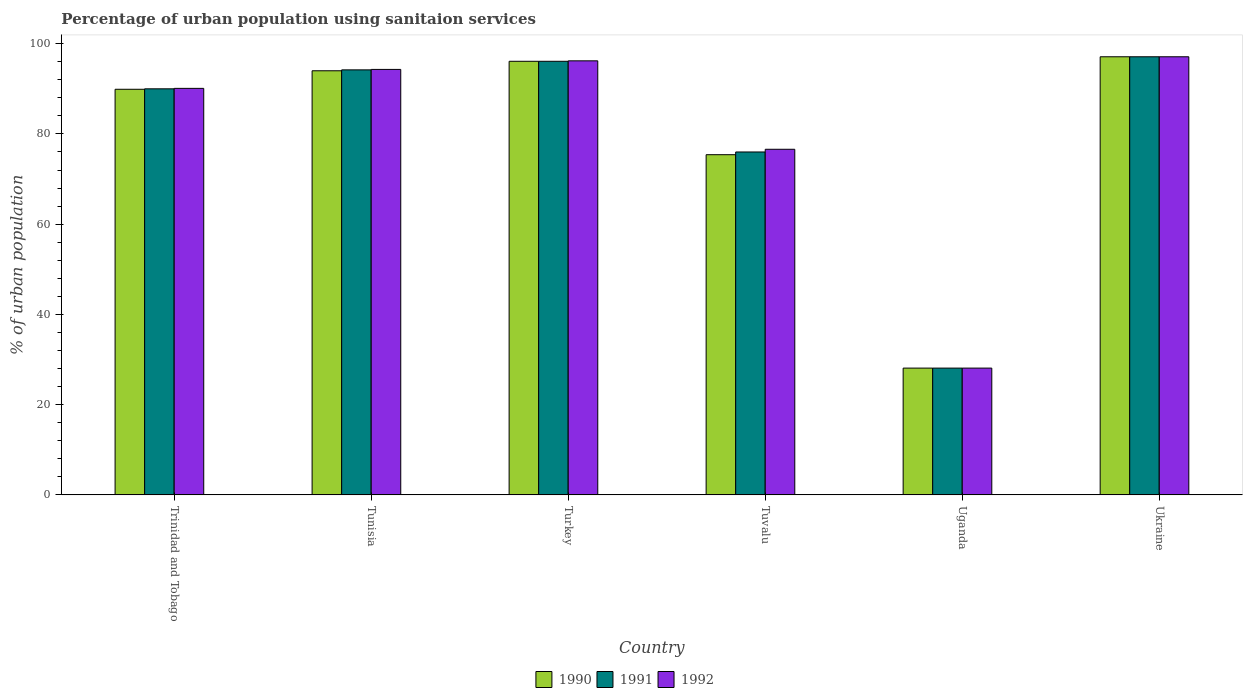How many different coloured bars are there?
Your answer should be very brief. 3. How many groups of bars are there?
Keep it short and to the point. 6. Are the number of bars per tick equal to the number of legend labels?
Offer a terse response. Yes. Are the number of bars on each tick of the X-axis equal?
Offer a terse response. Yes. How many bars are there on the 6th tick from the left?
Provide a succinct answer. 3. What is the label of the 4th group of bars from the left?
Offer a terse response. Tuvalu. What is the percentage of urban population using sanitaion services in 1992 in Trinidad and Tobago?
Your response must be concise. 90.1. Across all countries, what is the maximum percentage of urban population using sanitaion services in 1991?
Give a very brief answer. 97.1. Across all countries, what is the minimum percentage of urban population using sanitaion services in 1992?
Offer a very short reply. 28.1. In which country was the percentage of urban population using sanitaion services in 1992 maximum?
Your response must be concise. Ukraine. In which country was the percentage of urban population using sanitaion services in 1992 minimum?
Provide a succinct answer. Uganda. What is the total percentage of urban population using sanitaion services in 1990 in the graph?
Your answer should be compact. 480.6. What is the difference between the percentage of urban population using sanitaion services in 1992 in Trinidad and Tobago and the percentage of urban population using sanitaion services in 1990 in Uganda?
Ensure brevity in your answer.  62. What is the average percentage of urban population using sanitaion services in 1992 per country?
Offer a very short reply. 80.4. What is the difference between the percentage of urban population using sanitaion services of/in 1990 and percentage of urban population using sanitaion services of/in 1991 in Tuvalu?
Keep it short and to the point. -0.6. In how many countries, is the percentage of urban population using sanitaion services in 1991 greater than 44 %?
Your answer should be very brief. 5. What is the ratio of the percentage of urban population using sanitaion services in 1992 in Trinidad and Tobago to that in Uganda?
Your response must be concise. 3.21. Is the percentage of urban population using sanitaion services in 1991 in Tunisia less than that in Tuvalu?
Keep it short and to the point. No. What is the difference between the highest and the second highest percentage of urban population using sanitaion services in 1992?
Your answer should be compact. -0.9. What is the difference between the highest and the lowest percentage of urban population using sanitaion services in 1990?
Give a very brief answer. 69. What does the 3rd bar from the left in Ukraine represents?
Your answer should be compact. 1992. What does the 3rd bar from the right in Tuvalu represents?
Offer a very short reply. 1990. Is it the case that in every country, the sum of the percentage of urban population using sanitaion services in 1992 and percentage of urban population using sanitaion services in 1991 is greater than the percentage of urban population using sanitaion services in 1990?
Ensure brevity in your answer.  Yes. How many bars are there?
Offer a terse response. 18. Are all the bars in the graph horizontal?
Give a very brief answer. No. How many countries are there in the graph?
Keep it short and to the point. 6. Are the values on the major ticks of Y-axis written in scientific E-notation?
Your answer should be compact. No. Does the graph contain grids?
Make the answer very short. No. Where does the legend appear in the graph?
Offer a very short reply. Bottom center. How many legend labels are there?
Offer a very short reply. 3. What is the title of the graph?
Provide a succinct answer. Percentage of urban population using sanitaion services. What is the label or title of the Y-axis?
Keep it short and to the point. % of urban population. What is the % of urban population of 1990 in Trinidad and Tobago?
Your answer should be compact. 89.9. What is the % of urban population in 1991 in Trinidad and Tobago?
Keep it short and to the point. 90. What is the % of urban population in 1992 in Trinidad and Tobago?
Your response must be concise. 90.1. What is the % of urban population of 1990 in Tunisia?
Offer a very short reply. 94. What is the % of urban population of 1991 in Tunisia?
Offer a terse response. 94.2. What is the % of urban population in 1992 in Tunisia?
Provide a short and direct response. 94.3. What is the % of urban population in 1990 in Turkey?
Ensure brevity in your answer.  96.1. What is the % of urban population of 1991 in Turkey?
Provide a short and direct response. 96.1. What is the % of urban population in 1992 in Turkey?
Offer a terse response. 96.2. What is the % of urban population of 1990 in Tuvalu?
Give a very brief answer. 75.4. What is the % of urban population of 1992 in Tuvalu?
Offer a terse response. 76.6. What is the % of urban population of 1990 in Uganda?
Make the answer very short. 28.1. What is the % of urban population in 1991 in Uganda?
Provide a short and direct response. 28.1. What is the % of urban population of 1992 in Uganda?
Offer a terse response. 28.1. What is the % of urban population in 1990 in Ukraine?
Provide a succinct answer. 97.1. What is the % of urban population of 1991 in Ukraine?
Provide a short and direct response. 97.1. What is the % of urban population of 1992 in Ukraine?
Give a very brief answer. 97.1. Across all countries, what is the maximum % of urban population of 1990?
Offer a terse response. 97.1. Across all countries, what is the maximum % of urban population of 1991?
Your answer should be very brief. 97.1. Across all countries, what is the maximum % of urban population in 1992?
Provide a succinct answer. 97.1. Across all countries, what is the minimum % of urban population in 1990?
Your answer should be very brief. 28.1. Across all countries, what is the minimum % of urban population in 1991?
Give a very brief answer. 28.1. Across all countries, what is the minimum % of urban population in 1992?
Provide a succinct answer. 28.1. What is the total % of urban population of 1990 in the graph?
Provide a succinct answer. 480.6. What is the total % of urban population of 1991 in the graph?
Give a very brief answer. 481.5. What is the total % of urban population of 1992 in the graph?
Your answer should be compact. 482.4. What is the difference between the % of urban population in 1990 in Trinidad and Tobago and that in Tunisia?
Ensure brevity in your answer.  -4.1. What is the difference between the % of urban population in 1991 in Trinidad and Tobago and that in Tunisia?
Give a very brief answer. -4.2. What is the difference between the % of urban population in 1990 in Trinidad and Tobago and that in Turkey?
Give a very brief answer. -6.2. What is the difference between the % of urban population of 1992 in Trinidad and Tobago and that in Turkey?
Offer a very short reply. -6.1. What is the difference between the % of urban population of 1990 in Trinidad and Tobago and that in Tuvalu?
Offer a terse response. 14.5. What is the difference between the % of urban population in 1991 in Trinidad and Tobago and that in Tuvalu?
Keep it short and to the point. 14. What is the difference between the % of urban population in 1992 in Trinidad and Tobago and that in Tuvalu?
Your answer should be very brief. 13.5. What is the difference between the % of urban population of 1990 in Trinidad and Tobago and that in Uganda?
Make the answer very short. 61.8. What is the difference between the % of urban population of 1991 in Trinidad and Tobago and that in Uganda?
Keep it short and to the point. 61.9. What is the difference between the % of urban population in 1992 in Trinidad and Tobago and that in Uganda?
Make the answer very short. 62. What is the difference between the % of urban population in 1990 in Trinidad and Tobago and that in Ukraine?
Your response must be concise. -7.2. What is the difference between the % of urban population in 1991 in Trinidad and Tobago and that in Ukraine?
Make the answer very short. -7.1. What is the difference between the % of urban population in 1990 in Tunisia and that in Uganda?
Offer a terse response. 65.9. What is the difference between the % of urban population of 1991 in Tunisia and that in Uganda?
Your answer should be compact. 66.1. What is the difference between the % of urban population in 1992 in Tunisia and that in Uganda?
Ensure brevity in your answer.  66.2. What is the difference between the % of urban population of 1991 in Tunisia and that in Ukraine?
Your answer should be very brief. -2.9. What is the difference between the % of urban population in 1990 in Turkey and that in Tuvalu?
Make the answer very short. 20.7. What is the difference between the % of urban population in 1991 in Turkey and that in Tuvalu?
Offer a very short reply. 20.1. What is the difference between the % of urban population of 1992 in Turkey and that in Tuvalu?
Your answer should be very brief. 19.6. What is the difference between the % of urban population of 1991 in Turkey and that in Uganda?
Your answer should be very brief. 68. What is the difference between the % of urban population in 1992 in Turkey and that in Uganda?
Provide a succinct answer. 68.1. What is the difference between the % of urban population in 1991 in Turkey and that in Ukraine?
Your response must be concise. -1. What is the difference between the % of urban population in 1990 in Tuvalu and that in Uganda?
Offer a very short reply. 47.3. What is the difference between the % of urban population of 1991 in Tuvalu and that in Uganda?
Your response must be concise. 47.9. What is the difference between the % of urban population in 1992 in Tuvalu and that in Uganda?
Make the answer very short. 48.5. What is the difference between the % of urban population of 1990 in Tuvalu and that in Ukraine?
Provide a short and direct response. -21.7. What is the difference between the % of urban population of 1991 in Tuvalu and that in Ukraine?
Provide a short and direct response. -21.1. What is the difference between the % of urban population of 1992 in Tuvalu and that in Ukraine?
Give a very brief answer. -20.5. What is the difference between the % of urban population in 1990 in Uganda and that in Ukraine?
Your response must be concise. -69. What is the difference between the % of urban population in 1991 in Uganda and that in Ukraine?
Make the answer very short. -69. What is the difference between the % of urban population in 1992 in Uganda and that in Ukraine?
Offer a terse response. -69. What is the difference between the % of urban population in 1990 in Trinidad and Tobago and the % of urban population in 1992 in Tunisia?
Your response must be concise. -4.4. What is the difference between the % of urban population of 1990 in Trinidad and Tobago and the % of urban population of 1991 in Turkey?
Make the answer very short. -6.2. What is the difference between the % of urban population of 1990 in Trinidad and Tobago and the % of urban population of 1992 in Tuvalu?
Your answer should be compact. 13.3. What is the difference between the % of urban population of 1991 in Trinidad and Tobago and the % of urban population of 1992 in Tuvalu?
Your answer should be compact. 13.4. What is the difference between the % of urban population of 1990 in Trinidad and Tobago and the % of urban population of 1991 in Uganda?
Provide a short and direct response. 61.8. What is the difference between the % of urban population in 1990 in Trinidad and Tobago and the % of urban population in 1992 in Uganda?
Offer a terse response. 61.8. What is the difference between the % of urban population of 1991 in Trinidad and Tobago and the % of urban population of 1992 in Uganda?
Offer a terse response. 61.9. What is the difference between the % of urban population in 1990 in Trinidad and Tobago and the % of urban population in 1991 in Ukraine?
Provide a succinct answer. -7.2. What is the difference between the % of urban population of 1990 in Trinidad and Tobago and the % of urban population of 1992 in Ukraine?
Offer a terse response. -7.2. What is the difference between the % of urban population of 1991 in Trinidad and Tobago and the % of urban population of 1992 in Ukraine?
Provide a short and direct response. -7.1. What is the difference between the % of urban population of 1991 in Tunisia and the % of urban population of 1992 in Turkey?
Make the answer very short. -2. What is the difference between the % of urban population of 1991 in Tunisia and the % of urban population of 1992 in Tuvalu?
Make the answer very short. 17.6. What is the difference between the % of urban population of 1990 in Tunisia and the % of urban population of 1991 in Uganda?
Provide a succinct answer. 65.9. What is the difference between the % of urban population in 1990 in Tunisia and the % of urban population in 1992 in Uganda?
Provide a succinct answer. 65.9. What is the difference between the % of urban population in 1991 in Tunisia and the % of urban population in 1992 in Uganda?
Give a very brief answer. 66.1. What is the difference between the % of urban population in 1990 in Tunisia and the % of urban population in 1992 in Ukraine?
Make the answer very short. -3.1. What is the difference between the % of urban population in 1990 in Turkey and the % of urban population in 1991 in Tuvalu?
Your response must be concise. 20.1. What is the difference between the % of urban population in 1990 in Turkey and the % of urban population in 1992 in Tuvalu?
Make the answer very short. 19.5. What is the difference between the % of urban population of 1991 in Turkey and the % of urban population of 1992 in Tuvalu?
Provide a succinct answer. 19.5. What is the difference between the % of urban population in 1990 in Turkey and the % of urban population in 1992 in Uganda?
Your answer should be very brief. 68. What is the difference between the % of urban population of 1990 in Turkey and the % of urban population of 1991 in Ukraine?
Your response must be concise. -1. What is the difference between the % of urban population of 1990 in Turkey and the % of urban population of 1992 in Ukraine?
Provide a short and direct response. -1. What is the difference between the % of urban population of 1990 in Tuvalu and the % of urban population of 1991 in Uganda?
Provide a succinct answer. 47.3. What is the difference between the % of urban population of 1990 in Tuvalu and the % of urban population of 1992 in Uganda?
Provide a succinct answer. 47.3. What is the difference between the % of urban population in 1991 in Tuvalu and the % of urban population in 1992 in Uganda?
Ensure brevity in your answer.  47.9. What is the difference between the % of urban population of 1990 in Tuvalu and the % of urban population of 1991 in Ukraine?
Your answer should be very brief. -21.7. What is the difference between the % of urban population in 1990 in Tuvalu and the % of urban population in 1992 in Ukraine?
Your answer should be compact. -21.7. What is the difference between the % of urban population in 1991 in Tuvalu and the % of urban population in 1992 in Ukraine?
Keep it short and to the point. -21.1. What is the difference between the % of urban population in 1990 in Uganda and the % of urban population in 1991 in Ukraine?
Keep it short and to the point. -69. What is the difference between the % of urban population of 1990 in Uganda and the % of urban population of 1992 in Ukraine?
Your answer should be compact. -69. What is the difference between the % of urban population in 1991 in Uganda and the % of urban population in 1992 in Ukraine?
Make the answer very short. -69. What is the average % of urban population in 1990 per country?
Keep it short and to the point. 80.1. What is the average % of urban population in 1991 per country?
Provide a short and direct response. 80.25. What is the average % of urban population of 1992 per country?
Keep it short and to the point. 80.4. What is the difference between the % of urban population of 1990 and % of urban population of 1991 in Trinidad and Tobago?
Ensure brevity in your answer.  -0.1. What is the difference between the % of urban population in 1991 and % of urban population in 1992 in Trinidad and Tobago?
Offer a terse response. -0.1. What is the difference between the % of urban population in 1990 and % of urban population in 1991 in Tunisia?
Give a very brief answer. -0.2. What is the difference between the % of urban population of 1990 and % of urban population of 1991 in Turkey?
Ensure brevity in your answer.  0. What is the difference between the % of urban population in 1990 and % of urban population in 1992 in Turkey?
Your answer should be very brief. -0.1. What is the difference between the % of urban population of 1990 and % of urban population of 1991 in Tuvalu?
Provide a succinct answer. -0.6. What is the difference between the % of urban population in 1990 and % of urban population in 1992 in Uganda?
Provide a succinct answer. 0. What is the difference between the % of urban population of 1991 and % of urban population of 1992 in Uganda?
Give a very brief answer. 0. What is the difference between the % of urban population in 1990 and % of urban population in 1992 in Ukraine?
Your response must be concise. 0. What is the ratio of the % of urban population of 1990 in Trinidad and Tobago to that in Tunisia?
Ensure brevity in your answer.  0.96. What is the ratio of the % of urban population of 1991 in Trinidad and Tobago to that in Tunisia?
Provide a succinct answer. 0.96. What is the ratio of the % of urban population of 1992 in Trinidad and Tobago to that in Tunisia?
Give a very brief answer. 0.96. What is the ratio of the % of urban population in 1990 in Trinidad and Tobago to that in Turkey?
Offer a very short reply. 0.94. What is the ratio of the % of urban population in 1991 in Trinidad and Tobago to that in Turkey?
Offer a terse response. 0.94. What is the ratio of the % of urban population of 1992 in Trinidad and Tobago to that in Turkey?
Your answer should be compact. 0.94. What is the ratio of the % of urban population of 1990 in Trinidad and Tobago to that in Tuvalu?
Your answer should be compact. 1.19. What is the ratio of the % of urban population in 1991 in Trinidad and Tobago to that in Tuvalu?
Your answer should be compact. 1.18. What is the ratio of the % of urban population in 1992 in Trinidad and Tobago to that in Tuvalu?
Offer a terse response. 1.18. What is the ratio of the % of urban population of 1990 in Trinidad and Tobago to that in Uganda?
Your answer should be compact. 3.2. What is the ratio of the % of urban population of 1991 in Trinidad and Tobago to that in Uganda?
Keep it short and to the point. 3.2. What is the ratio of the % of urban population of 1992 in Trinidad and Tobago to that in Uganda?
Ensure brevity in your answer.  3.21. What is the ratio of the % of urban population of 1990 in Trinidad and Tobago to that in Ukraine?
Give a very brief answer. 0.93. What is the ratio of the % of urban population in 1991 in Trinidad and Tobago to that in Ukraine?
Your response must be concise. 0.93. What is the ratio of the % of urban population of 1992 in Trinidad and Tobago to that in Ukraine?
Your response must be concise. 0.93. What is the ratio of the % of urban population of 1990 in Tunisia to that in Turkey?
Your answer should be compact. 0.98. What is the ratio of the % of urban population in 1991 in Tunisia to that in Turkey?
Give a very brief answer. 0.98. What is the ratio of the % of urban population in 1992 in Tunisia to that in Turkey?
Your response must be concise. 0.98. What is the ratio of the % of urban population of 1990 in Tunisia to that in Tuvalu?
Offer a terse response. 1.25. What is the ratio of the % of urban population of 1991 in Tunisia to that in Tuvalu?
Provide a short and direct response. 1.24. What is the ratio of the % of urban population of 1992 in Tunisia to that in Tuvalu?
Your answer should be very brief. 1.23. What is the ratio of the % of urban population in 1990 in Tunisia to that in Uganda?
Provide a short and direct response. 3.35. What is the ratio of the % of urban population of 1991 in Tunisia to that in Uganda?
Give a very brief answer. 3.35. What is the ratio of the % of urban population of 1992 in Tunisia to that in Uganda?
Your answer should be compact. 3.36. What is the ratio of the % of urban population of 1990 in Tunisia to that in Ukraine?
Make the answer very short. 0.97. What is the ratio of the % of urban population of 1991 in Tunisia to that in Ukraine?
Provide a succinct answer. 0.97. What is the ratio of the % of urban population in 1992 in Tunisia to that in Ukraine?
Make the answer very short. 0.97. What is the ratio of the % of urban population in 1990 in Turkey to that in Tuvalu?
Your answer should be very brief. 1.27. What is the ratio of the % of urban population of 1991 in Turkey to that in Tuvalu?
Your response must be concise. 1.26. What is the ratio of the % of urban population of 1992 in Turkey to that in Tuvalu?
Ensure brevity in your answer.  1.26. What is the ratio of the % of urban population in 1990 in Turkey to that in Uganda?
Provide a short and direct response. 3.42. What is the ratio of the % of urban population of 1991 in Turkey to that in Uganda?
Keep it short and to the point. 3.42. What is the ratio of the % of urban population of 1992 in Turkey to that in Uganda?
Offer a very short reply. 3.42. What is the ratio of the % of urban population in 1990 in Turkey to that in Ukraine?
Make the answer very short. 0.99. What is the ratio of the % of urban population of 1990 in Tuvalu to that in Uganda?
Provide a succinct answer. 2.68. What is the ratio of the % of urban population of 1991 in Tuvalu to that in Uganda?
Your response must be concise. 2.7. What is the ratio of the % of urban population in 1992 in Tuvalu to that in Uganda?
Offer a very short reply. 2.73. What is the ratio of the % of urban population in 1990 in Tuvalu to that in Ukraine?
Your answer should be compact. 0.78. What is the ratio of the % of urban population in 1991 in Tuvalu to that in Ukraine?
Offer a terse response. 0.78. What is the ratio of the % of urban population in 1992 in Tuvalu to that in Ukraine?
Give a very brief answer. 0.79. What is the ratio of the % of urban population in 1990 in Uganda to that in Ukraine?
Offer a terse response. 0.29. What is the ratio of the % of urban population in 1991 in Uganda to that in Ukraine?
Ensure brevity in your answer.  0.29. What is the ratio of the % of urban population in 1992 in Uganda to that in Ukraine?
Ensure brevity in your answer.  0.29. What is the difference between the highest and the second highest % of urban population in 1990?
Provide a short and direct response. 1. What is the difference between the highest and the second highest % of urban population of 1991?
Offer a terse response. 1. What is the difference between the highest and the second highest % of urban population in 1992?
Your answer should be compact. 0.9. What is the difference between the highest and the lowest % of urban population of 1990?
Ensure brevity in your answer.  69. What is the difference between the highest and the lowest % of urban population of 1991?
Provide a short and direct response. 69. What is the difference between the highest and the lowest % of urban population in 1992?
Your response must be concise. 69. 